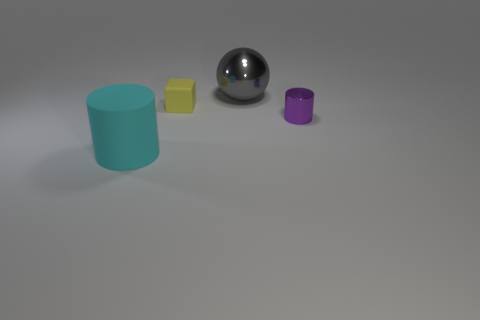How many other objects are the same shape as the cyan rubber object?
Provide a succinct answer. 1. There is a large metal thing; is it the same shape as the small yellow rubber thing that is behind the large rubber cylinder?
Give a very brief answer. No. Is there anything else that is the same material as the large cylinder?
Ensure brevity in your answer.  Yes. There is a cyan thing that is the same shape as the tiny purple object; what is it made of?
Provide a short and direct response. Rubber. What number of large things are gray metal objects or metal blocks?
Provide a short and direct response. 1. Are there fewer gray objects that are in front of the small yellow thing than purple shiny cylinders that are to the right of the metallic ball?
Provide a short and direct response. Yes. How many things are either small yellow things or purple metallic cylinders?
Ensure brevity in your answer.  2. What number of large gray balls are on the right side of the tiny yellow cube?
Keep it short and to the point. 1. There is a yellow object that is made of the same material as the large cyan cylinder; what shape is it?
Give a very brief answer. Cube. There is a thing on the left side of the tiny yellow thing; is it the same shape as the purple thing?
Your response must be concise. Yes. 